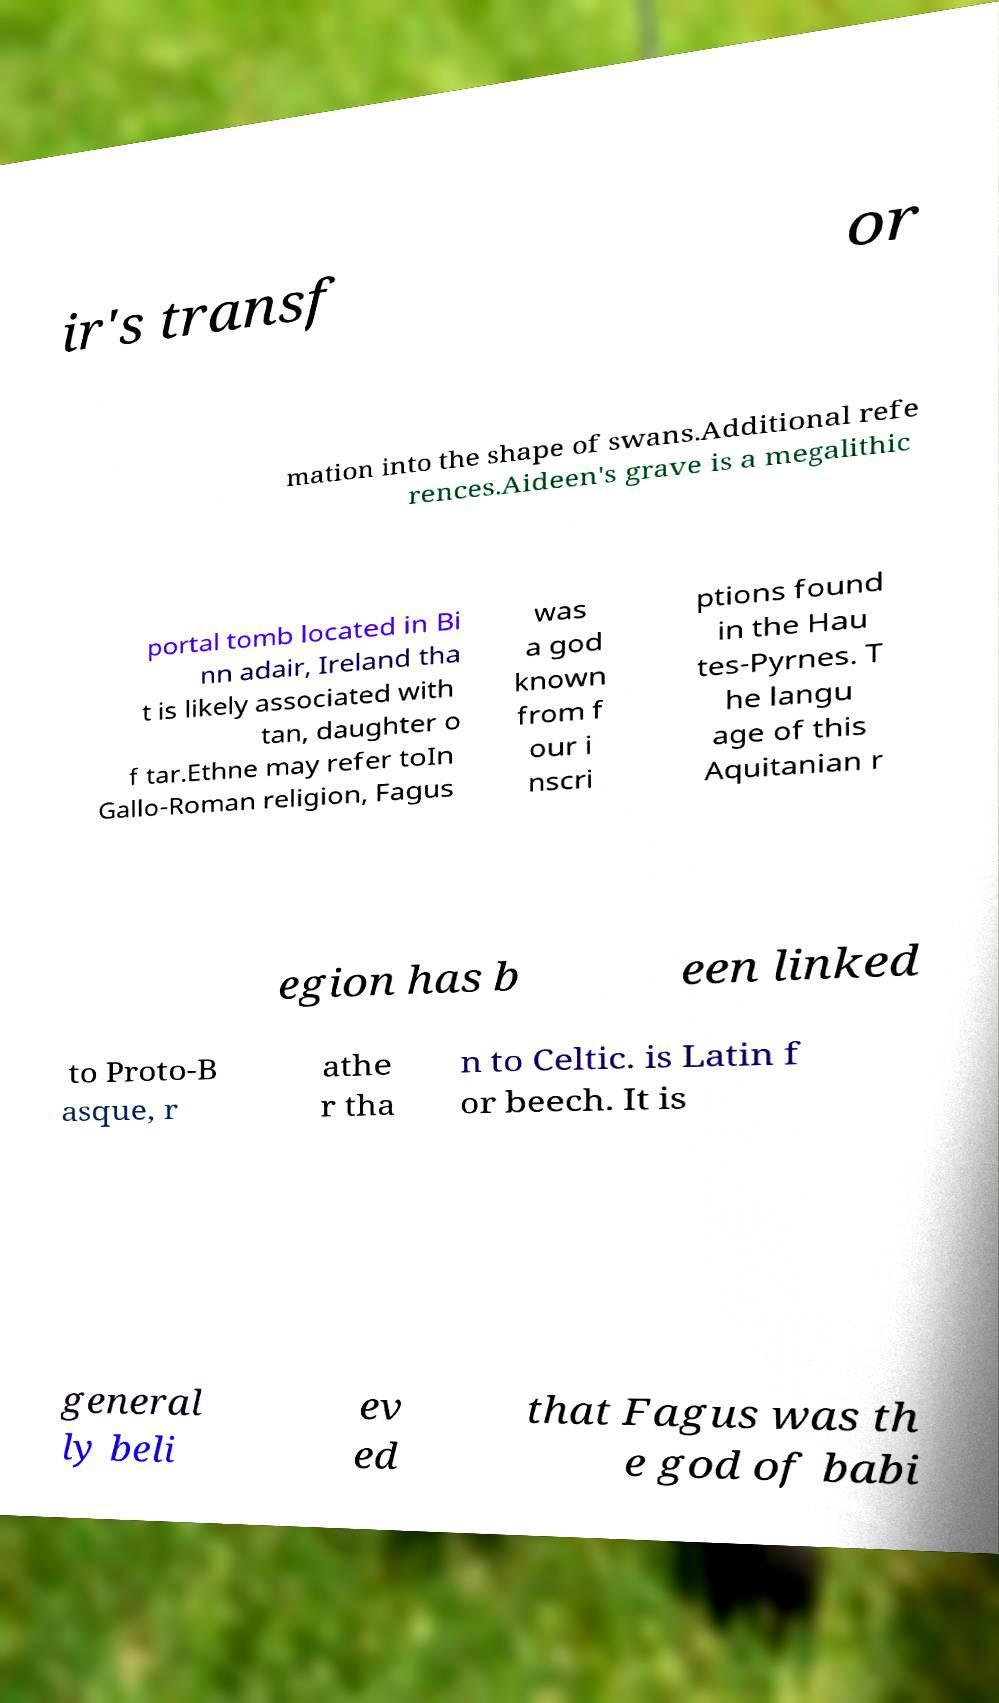For documentation purposes, I need the text within this image transcribed. Could you provide that? ir's transf or mation into the shape of swans.Additional refe rences.Aideen's grave is a megalithic portal tomb located in Bi nn adair, Ireland tha t is likely associated with tan, daughter o f tar.Ethne may refer toIn Gallo-Roman religion, Fagus was a god known from f our i nscri ptions found in the Hau tes-Pyrnes. T he langu age of this Aquitanian r egion has b een linked to Proto-B asque, r athe r tha n to Celtic. is Latin f or beech. It is general ly beli ev ed that Fagus was th e god of babi 